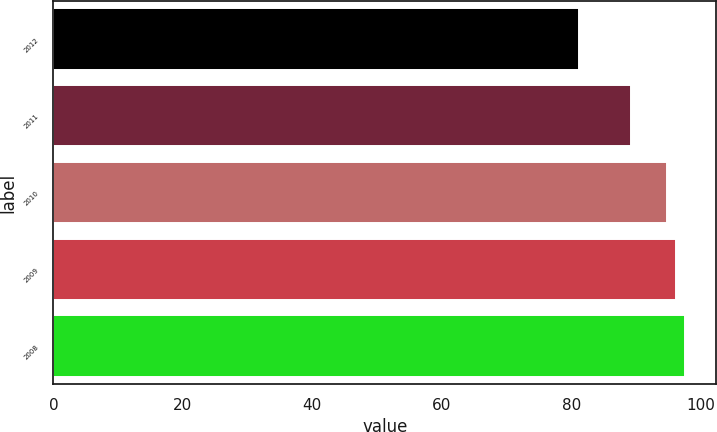<chart> <loc_0><loc_0><loc_500><loc_500><bar_chart><fcel>2012<fcel>2011<fcel>2010<fcel>2009<fcel>2008<nl><fcel>81.2<fcel>89.3<fcel>94.8<fcel>96.19<fcel>97.58<nl></chart> 